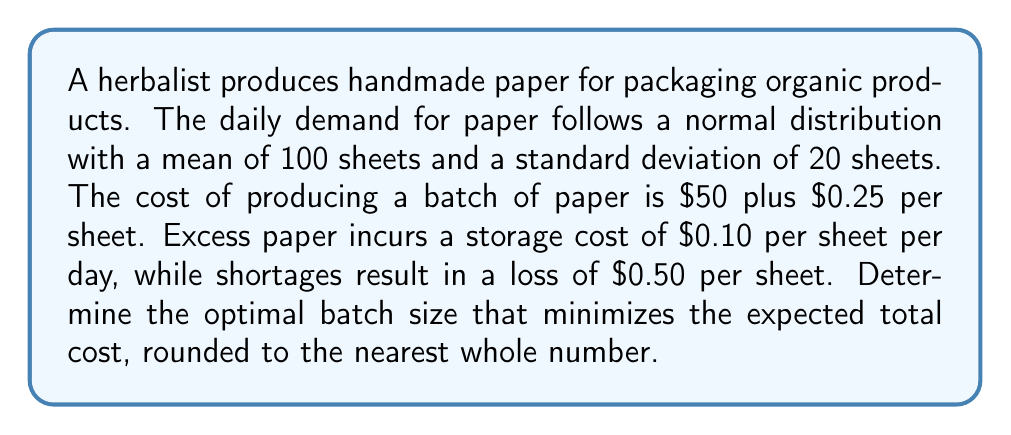Teach me how to tackle this problem. To determine the optimal batch size, we'll use the newsvendor model from inventory management theory.

Step 1: Calculate the critical fractile (CF)
$$ CF = \frac{c_u}{c_u + c_o} $$
Where $c_u$ is the underage cost and $c_o$ is the overage cost.
$c_u = 0.50$ (loss per sheet shortage)
$c_o = 0.10$ (storage cost per sheet)

$$ CF = \frac{0.50}{0.50 + 0.10} = \frac{5}{6} \approx 0.8333 $$

Step 2: Find the z-score corresponding to the critical fractile
Using a standard normal distribution table or calculator, we find that the z-score for 0.8333 is approximately 0.97.

Step 3: Calculate the optimal batch size (Q*)
$$ Q* = \mu + z\sigma $$
Where $\mu$ is the mean demand and $\sigma$ is the standard deviation.

$$ Q* = 100 + (0.97 \times 20) = 100 + 19.4 = 119.4 $$

Step 4: Round to the nearest whole number
The optimal batch size is 119 sheets of handmade paper.

Step 5: Verify that this minimizes expected total cost
The expected total cost (ETC) for a batch size Q is:
$$ ETC(Q) = 50 + 0.25Q + 0.10E[(Q-D)^+] + 0.50E[(D-Q)^+] $$
Where $E[(Q-D)^+]$ is the expected overage and $E[(D-Q)^+]$ is the expected underage.

We can confirm that Q = 119 minimizes this cost function using numerical methods or by comparing nearby integer values.
Answer: 119 sheets 